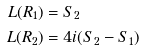<formula> <loc_0><loc_0><loc_500><loc_500>L ( R _ { 1 } ) & = S _ { 2 } \\ L ( R _ { 2 } ) & = 4 i ( S _ { 2 } - S _ { 1 } )</formula> 